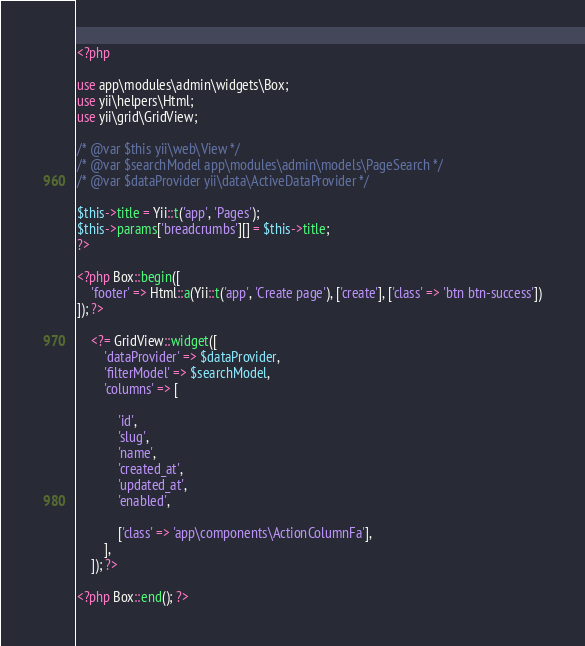Convert code to text. <code><loc_0><loc_0><loc_500><loc_500><_PHP_><?php

use app\modules\admin\widgets\Box;
use yii\helpers\Html;
use yii\grid\GridView;

/* @var $this yii\web\View */
/* @var $searchModel app\modules\admin\models\PageSearch */
/* @var $dataProvider yii\data\ActiveDataProvider */

$this->title = Yii::t('app', 'Pages');
$this->params['breadcrumbs'][] = $this->title;
?>

<?php Box::begin([
    'footer' => Html::a(Yii::t('app', 'Create page'), ['create'], ['class' => 'btn btn-success'])
]); ?>

    <?= GridView::widget([
        'dataProvider' => $dataProvider,
        'filterModel' => $searchModel,
        'columns' => [

            'id',
            'slug',
            'name',
            'created_at',
            'updated_at',
            'enabled',

            ['class' => 'app\components\ActionColumnFa'],
        ],
    ]); ?>

<?php Box::end(); ?>
</code> 